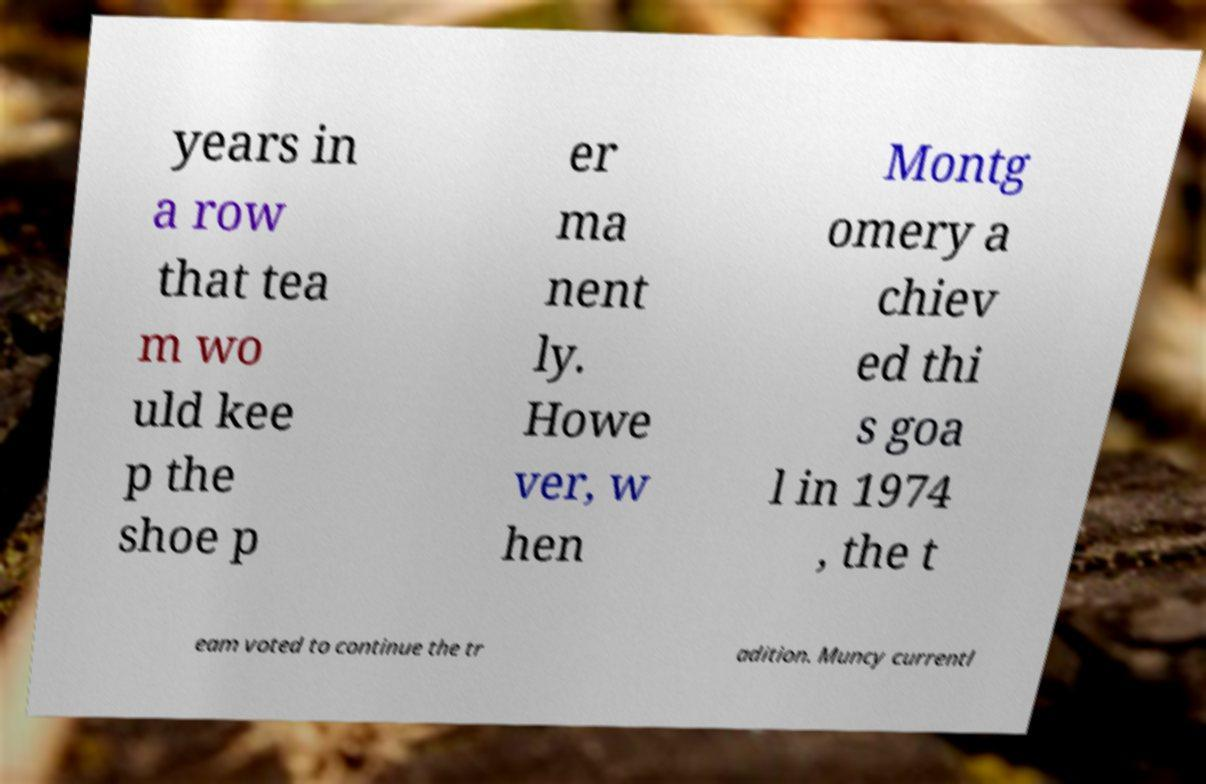Can you read and provide the text displayed in the image?This photo seems to have some interesting text. Can you extract and type it out for me? years in a row that tea m wo uld kee p the shoe p er ma nent ly. Howe ver, w hen Montg omery a chiev ed thi s goa l in 1974 , the t eam voted to continue the tr adition. Muncy currentl 